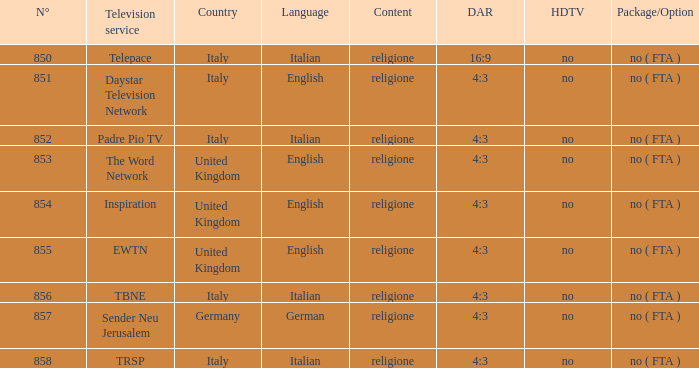In italy, what television service provides content in english? Daystar Television Network. 